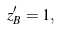Convert formula to latex. <formula><loc_0><loc_0><loc_500><loc_500>z _ { B } ^ { \prime } = 1 ,</formula> 